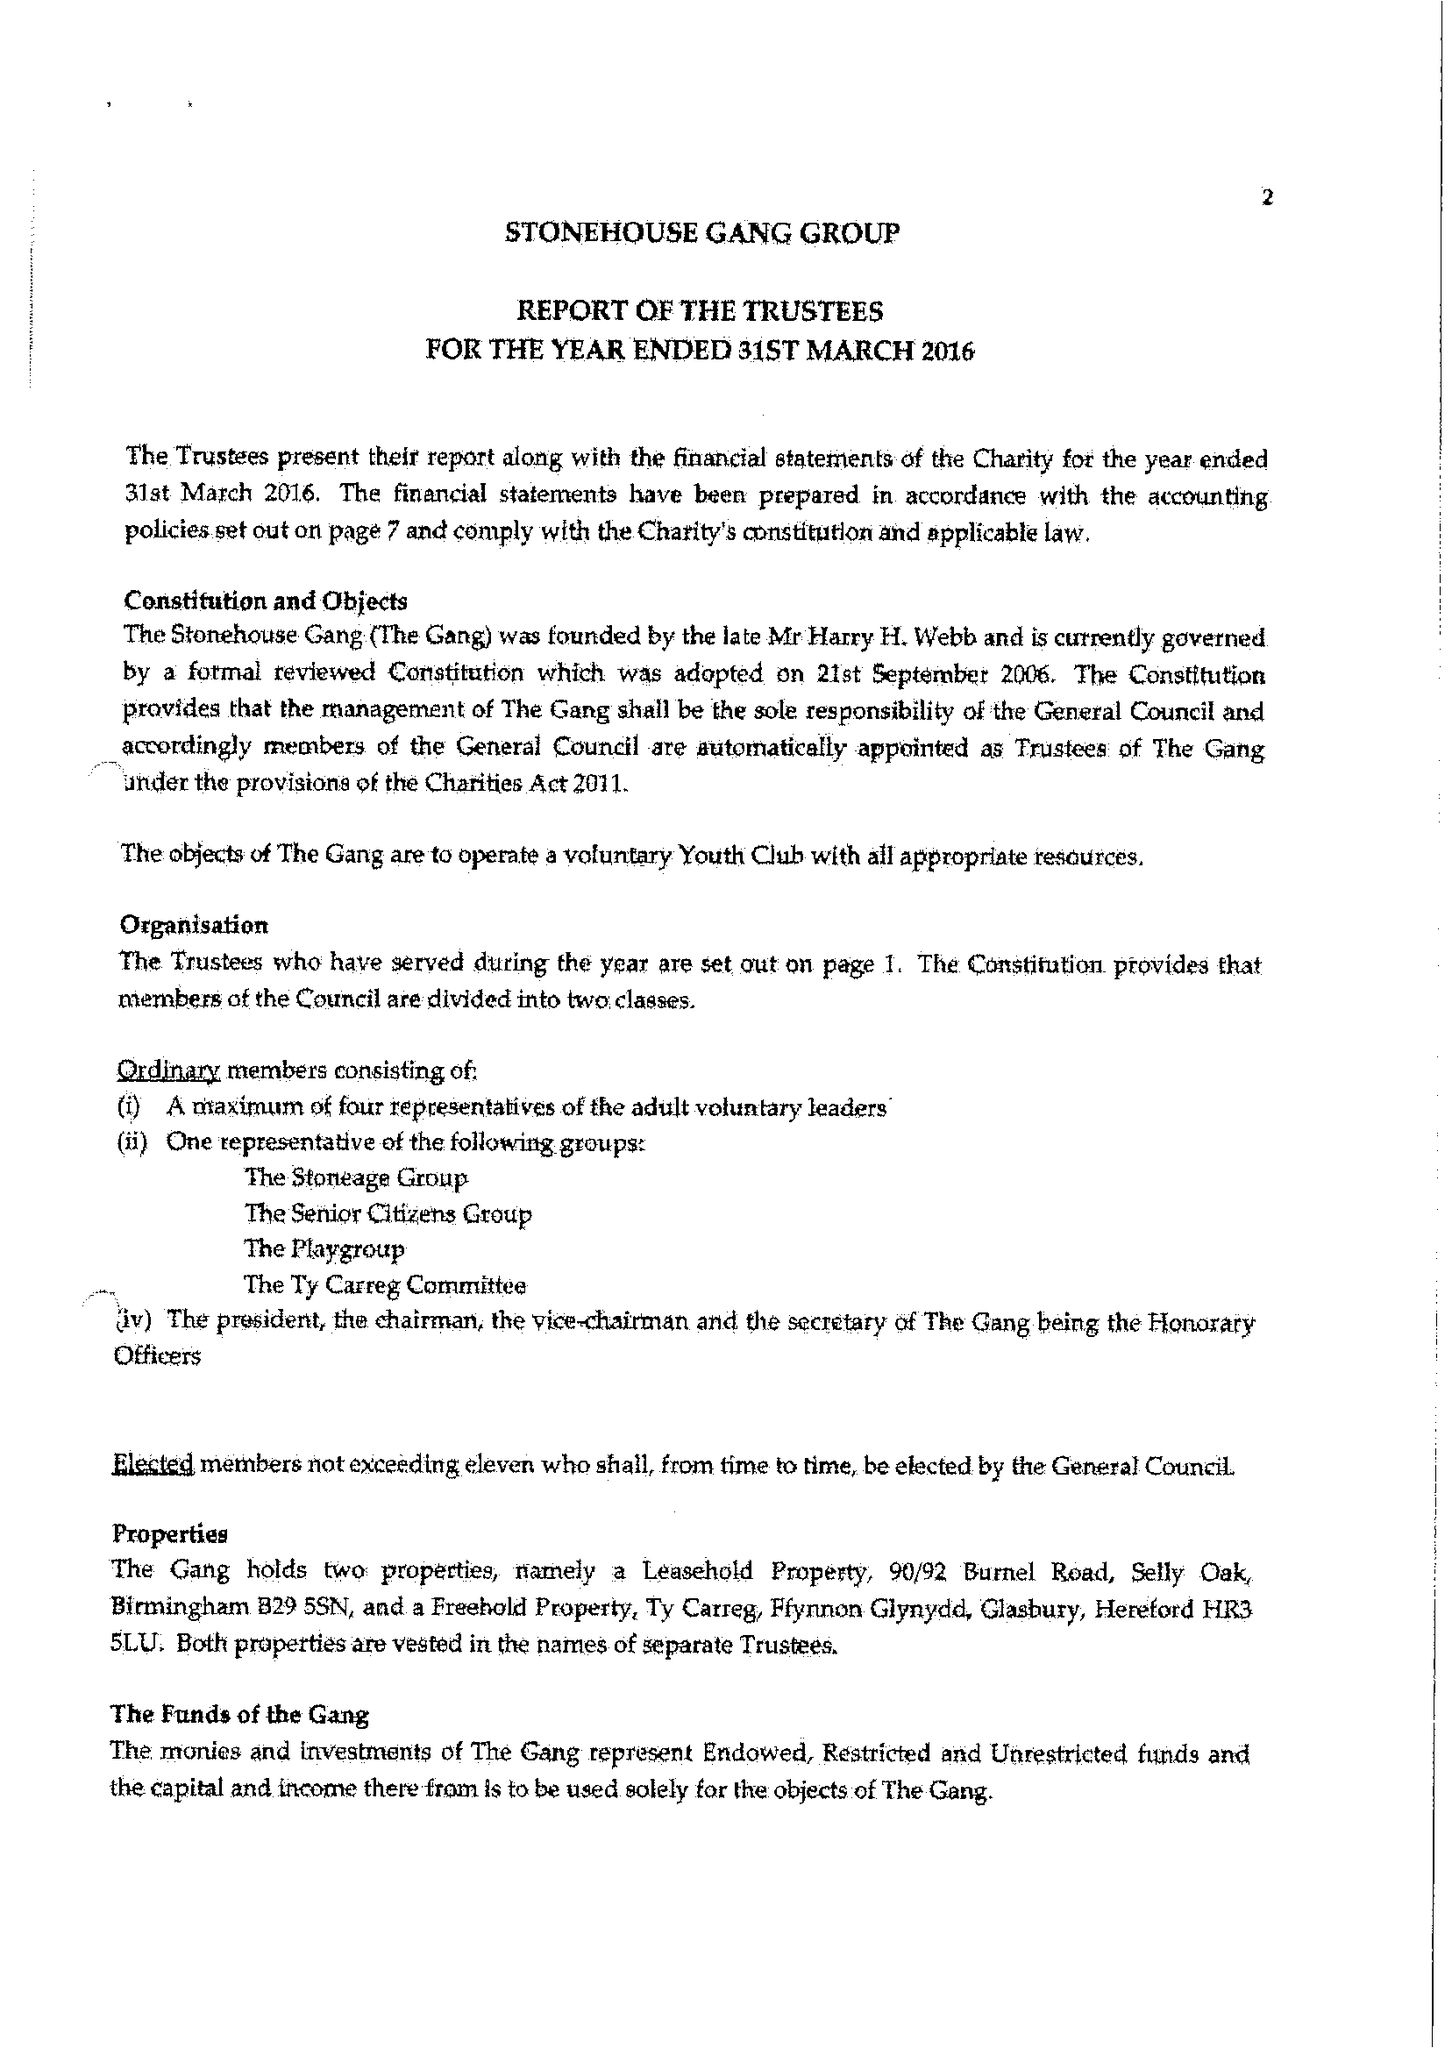What is the value for the address__post_town?
Answer the question using a single word or phrase. BEWDLEY 